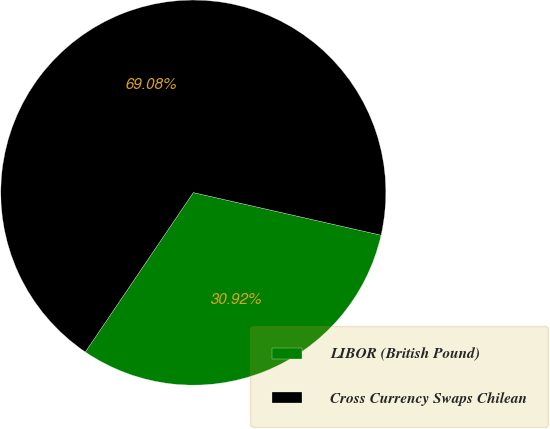Convert chart. <chart><loc_0><loc_0><loc_500><loc_500><pie_chart><fcel>LIBOR (British Pound)<fcel>Cross Currency Swaps Chilean<nl><fcel>30.92%<fcel>69.08%<nl></chart> 